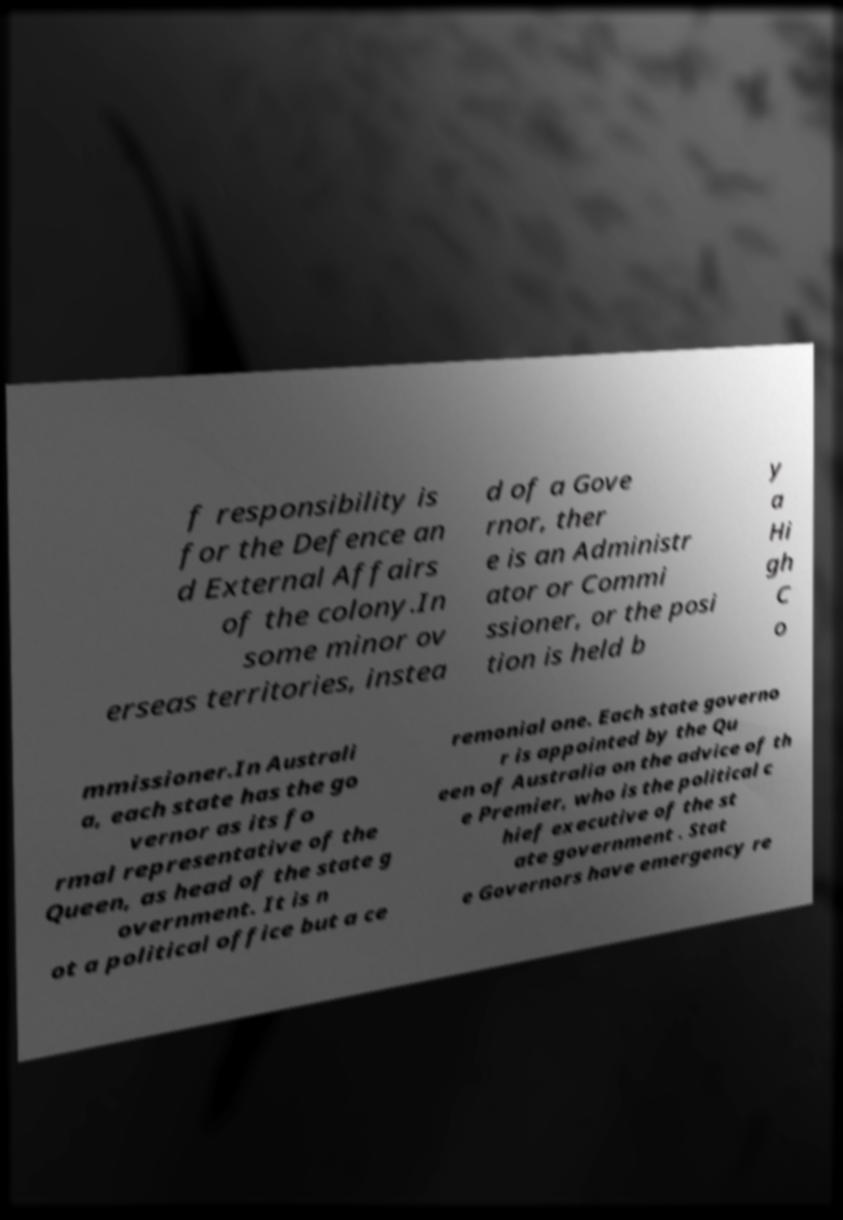I need the written content from this picture converted into text. Can you do that? f responsibility is for the Defence an d External Affairs of the colony.In some minor ov erseas territories, instea d of a Gove rnor, ther e is an Administr ator or Commi ssioner, or the posi tion is held b y a Hi gh C o mmissioner.In Australi a, each state has the go vernor as its fo rmal representative of the Queen, as head of the state g overnment. It is n ot a political office but a ce remonial one. Each state governo r is appointed by the Qu een of Australia on the advice of th e Premier, who is the political c hief executive of the st ate government . Stat e Governors have emergency re 